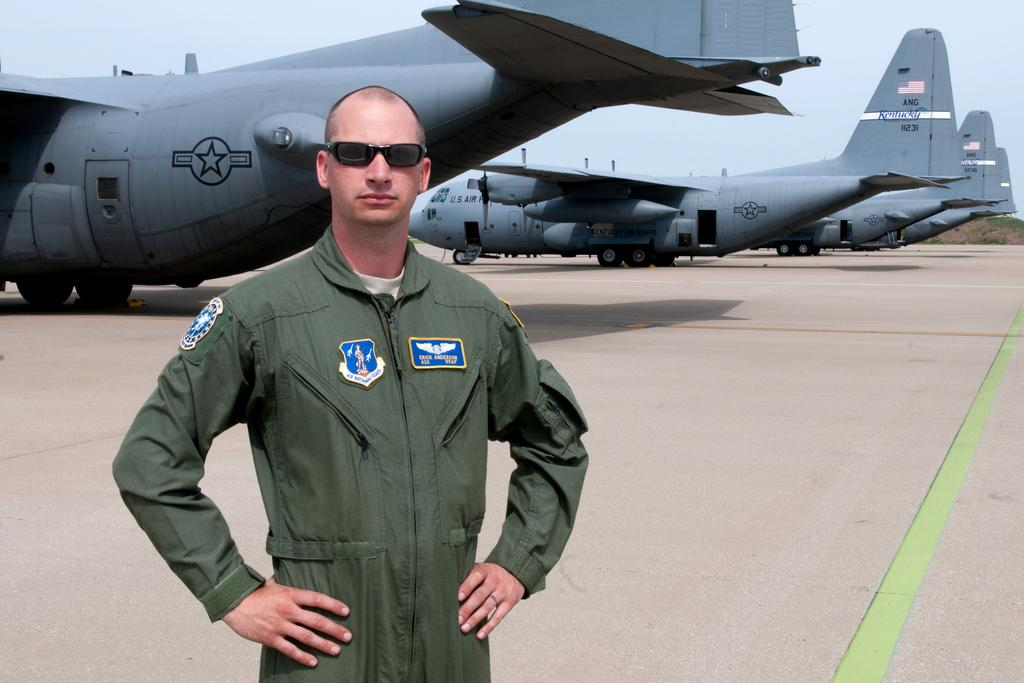Who is present in the image? There is a man in the image. What is the man wearing on his face? The man is wearing goggles. What is the man's posture in the image? The man is standing. What type of vehicles can be seen on the ground in the image? There are airplanes on the ground in the image. What type of natural environment is visible in the background of the image? There is grass visible in the background of the image. What is visible in the sky in the background of the image? The sky is visible in the background of the image. What type of wool is being used for the man's treatment in the image? There is no wool or treatment visible in the image; the man is simply wearing goggles and standing. 